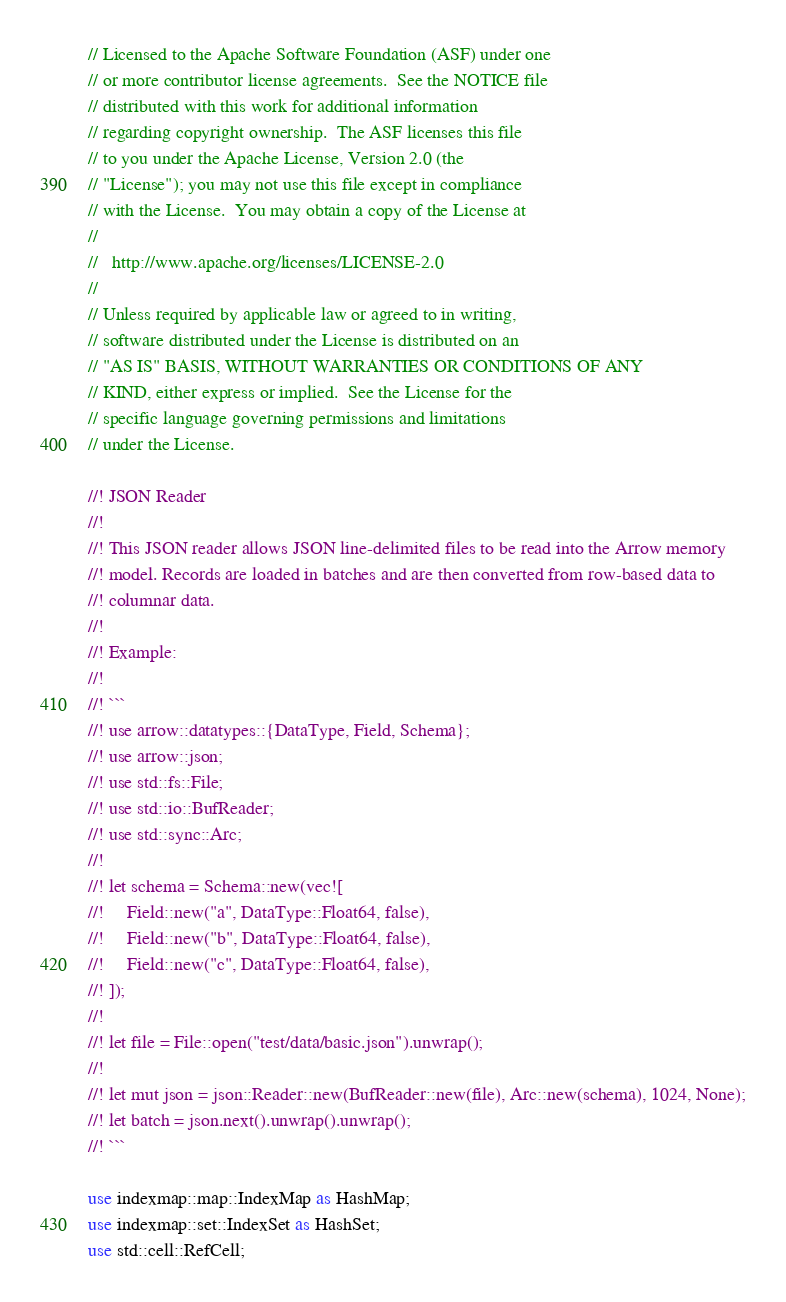<code> <loc_0><loc_0><loc_500><loc_500><_Rust_>// Licensed to the Apache Software Foundation (ASF) under one
// or more contributor license agreements.  See the NOTICE file
// distributed with this work for additional information
// regarding copyright ownership.  The ASF licenses this file
// to you under the Apache License, Version 2.0 (the
// "License"); you may not use this file except in compliance
// with the License.  You may obtain a copy of the License at
//
//   http://www.apache.org/licenses/LICENSE-2.0
//
// Unless required by applicable law or agreed to in writing,
// software distributed under the License is distributed on an
// "AS IS" BASIS, WITHOUT WARRANTIES OR CONDITIONS OF ANY
// KIND, either express or implied.  See the License for the
// specific language governing permissions and limitations
// under the License.

//! JSON Reader
//!
//! This JSON reader allows JSON line-delimited files to be read into the Arrow memory
//! model. Records are loaded in batches and are then converted from row-based data to
//! columnar data.
//!
//! Example:
//!
//! ```
//! use arrow::datatypes::{DataType, Field, Schema};
//! use arrow::json;
//! use std::fs::File;
//! use std::io::BufReader;
//! use std::sync::Arc;
//!
//! let schema = Schema::new(vec![
//!     Field::new("a", DataType::Float64, false),
//!     Field::new("b", DataType::Float64, false),
//!     Field::new("c", DataType::Float64, false),
//! ]);
//!
//! let file = File::open("test/data/basic.json").unwrap();
//!
//! let mut json = json::Reader::new(BufReader::new(file), Arc::new(schema), 1024, None);
//! let batch = json.next().unwrap().unwrap();
//! ```

use indexmap::map::IndexMap as HashMap;
use indexmap::set::IndexSet as HashSet;
use std::cell::RefCell;</code> 